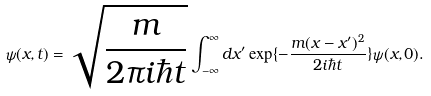<formula> <loc_0><loc_0><loc_500><loc_500>\psi ( x , t ) = \sqrt { \frac { m } { 2 \pi i \hbar { t } } } \int _ { - \infty } ^ { \infty } d x ^ { \prime } \exp \{ - \frac { m ( x - x ^ { \prime } ) ^ { 2 } } { 2 i \hbar { t } } \} \psi ( x , 0 ) .</formula> 